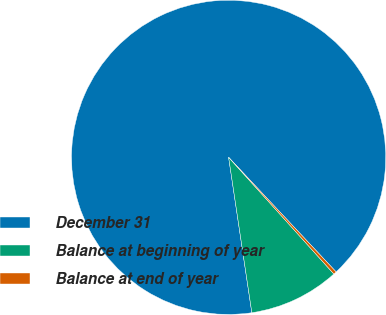Convert chart to OTSL. <chart><loc_0><loc_0><loc_500><loc_500><pie_chart><fcel>December 31<fcel>Balance at beginning of year<fcel>Balance at end of year<nl><fcel>90.37%<fcel>9.32%<fcel>0.31%<nl></chart> 